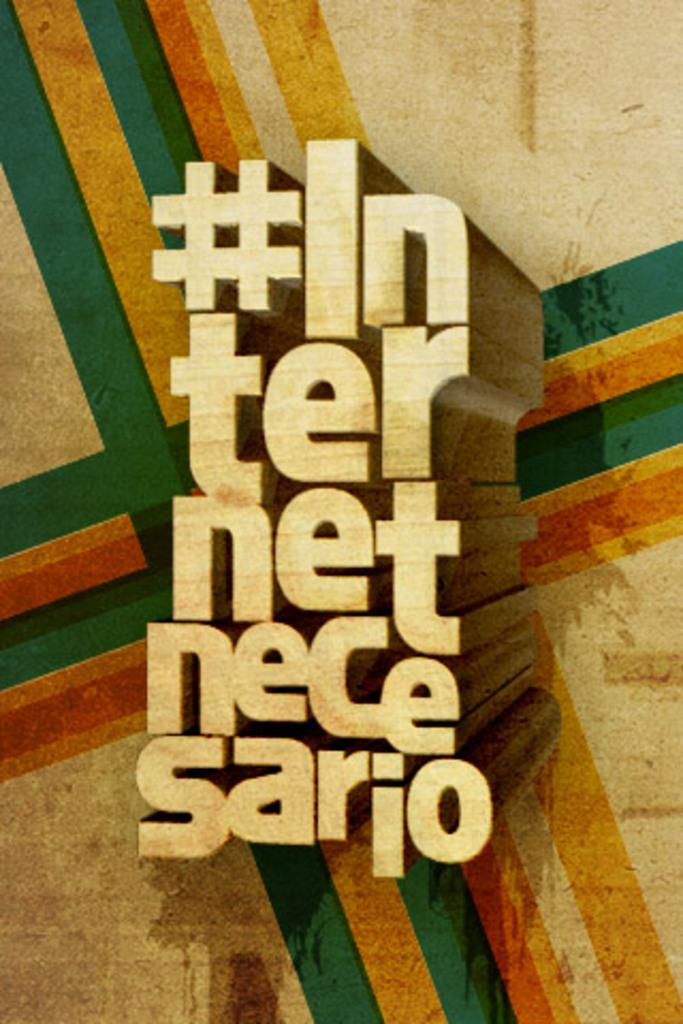What is present in the image? There is a poster in the image. What can be found in the middle of the poster? There is text in the middle of the poster. Can you see any mountains in the image? There are no mountains present in the image; it only features a poster with text in the middle. What type of doll is shown interacting with the trucks in the image? There is no doll or trucks present in the image; it only features a poster with text in the middle. 